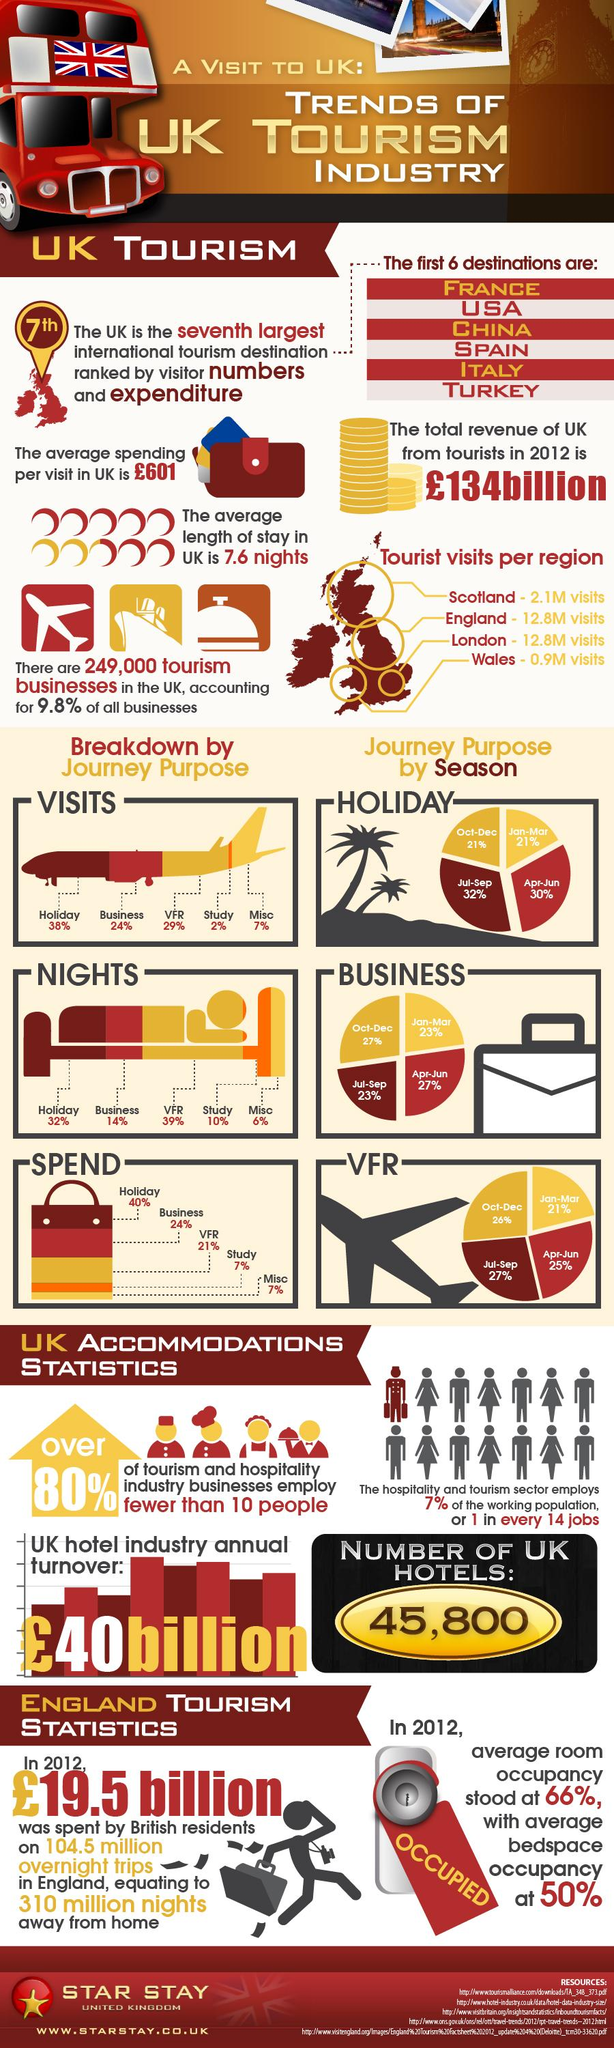Specify some key components in this picture. The last three international tourism destinations ranked by visitor numbers and expenditures are Italy, Turkey, and the UK. As per the map, England and London both receive the same number of visitors. The majority of visitors come for the purpose of vacation. According to the data, 90.2% of businesses in the city do not account for tourism. Business is the second most common reason for spending among our users. 